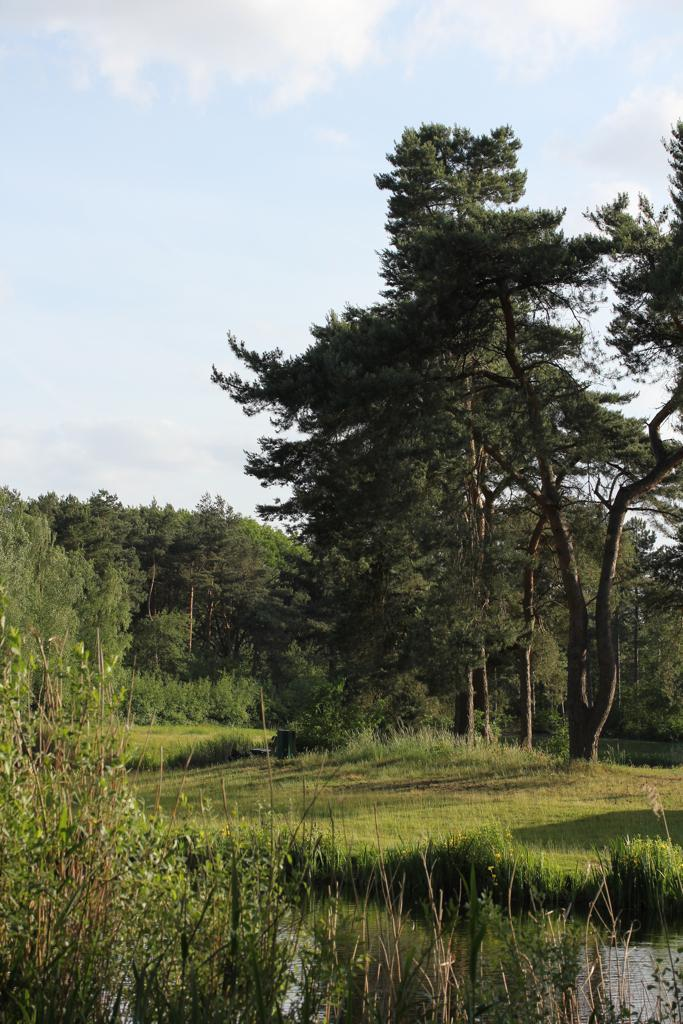What is one of the natural elements present in the image? There is water in the image. What type of vegetation can be seen in the image? There is grass in the image. What can be observed as a result of the interaction between the sun and objects in the image? Shadows are visible in the image. What type of plant life is present in the image? There are trees in the image. What can be seen in the sky in the image? Clouds are present in the image. What part of the sky is visible in the image? The sky is visible in the image. What type of knife is being used to cut the clouds in the image? There is no knife present in the image, nor are the clouds being cut. 